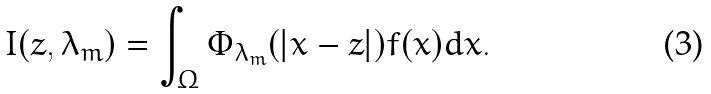Convert formula to latex. <formula><loc_0><loc_0><loc_500><loc_500>I ( z , \lambda _ { m } ) = \int _ { \Omega } \Phi _ { \lambda _ { m } } ( | x - z | ) f ( x ) d x .</formula> 